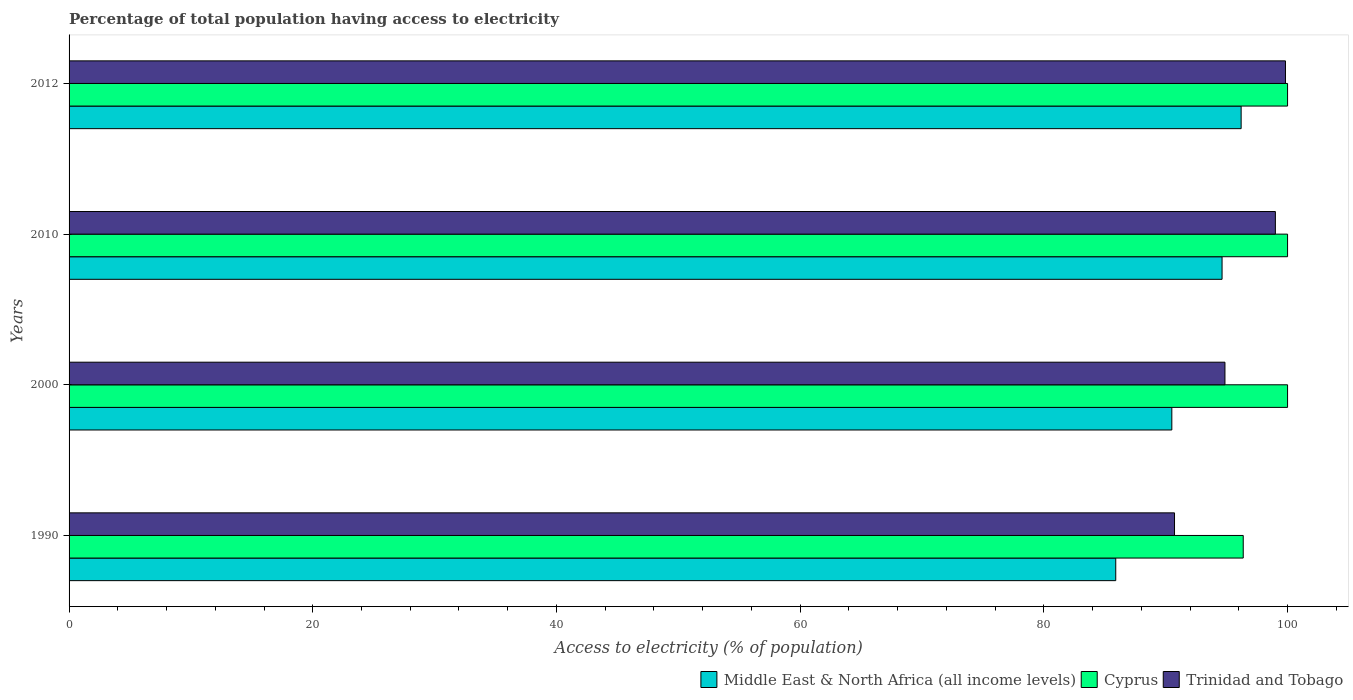How many different coloured bars are there?
Provide a short and direct response. 3. What is the label of the 2nd group of bars from the top?
Your answer should be compact. 2010. In how many cases, is the number of bars for a given year not equal to the number of legend labels?
Keep it short and to the point. 0. What is the percentage of population that have access to electricity in Middle East & North Africa (all income levels) in 2010?
Make the answer very short. 94.62. Across all years, what is the maximum percentage of population that have access to electricity in Cyprus?
Your answer should be compact. 100. Across all years, what is the minimum percentage of population that have access to electricity in Trinidad and Tobago?
Make the answer very short. 90.72. What is the total percentage of population that have access to electricity in Middle East & North Africa (all income levels) in the graph?
Your response must be concise. 367.21. What is the difference between the percentage of population that have access to electricity in Middle East & North Africa (all income levels) in 1990 and that in 2010?
Offer a very short reply. -8.73. What is the difference between the percentage of population that have access to electricity in Trinidad and Tobago in 1990 and the percentage of population that have access to electricity in Cyprus in 2010?
Keep it short and to the point. -9.28. What is the average percentage of population that have access to electricity in Middle East & North Africa (all income levels) per year?
Give a very brief answer. 91.8. In the year 1990, what is the difference between the percentage of population that have access to electricity in Trinidad and Tobago and percentage of population that have access to electricity in Middle East & North Africa (all income levels)?
Keep it short and to the point. 4.82. What is the ratio of the percentage of population that have access to electricity in Cyprus in 1990 to that in 2000?
Provide a succinct answer. 0.96. Is the difference between the percentage of population that have access to electricity in Trinidad and Tobago in 1990 and 2012 greater than the difference between the percentage of population that have access to electricity in Middle East & North Africa (all income levels) in 1990 and 2012?
Offer a very short reply. Yes. What is the difference between the highest and the lowest percentage of population that have access to electricity in Trinidad and Tobago?
Offer a very short reply. 9.11. Is the sum of the percentage of population that have access to electricity in Middle East & North Africa (all income levels) in 2000 and 2010 greater than the maximum percentage of population that have access to electricity in Trinidad and Tobago across all years?
Your answer should be very brief. Yes. What does the 2nd bar from the top in 1990 represents?
Your answer should be compact. Cyprus. What does the 3rd bar from the bottom in 2010 represents?
Your answer should be very brief. Trinidad and Tobago. Is it the case that in every year, the sum of the percentage of population that have access to electricity in Trinidad and Tobago and percentage of population that have access to electricity in Middle East & North Africa (all income levels) is greater than the percentage of population that have access to electricity in Cyprus?
Offer a terse response. Yes. How many bars are there?
Your response must be concise. 12. What is the difference between two consecutive major ticks on the X-axis?
Provide a succinct answer. 20. Are the values on the major ticks of X-axis written in scientific E-notation?
Your answer should be very brief. No. How many legend labels are there?
Offer a terse response. 3. How are the legend labels stacked?
Give a very brief answer. Horizontal. What is the title of the graph?
Make the answer very short. Percentage of total population having access to electricity. What is the label or title of the X-axis?
Make the answer very short. Access to electricity (% of population). What is the label or title of the Y-axis?
Provide a succinct answer. Years. What is the Access to electricity (% of population) in Middle East & North Africa (all income levels) in 1990?
Keep it short and to the point. 85.9. What is the Access to electricity (% of population) in Cyprus in 1990?
Provide a short and direct response. 96.36. What is the Access to electricity (% of population) of Trinidad and Tobago in 1990?
Offer a terse response. 90.72. What is the Access to electricity (% of population) in Middle East & North Africa (all income levels) in 2000?
Give a very brief answer. 90.5. What is the Access to electricity (% of population) of Cyprus in 2000?
Your response must be concise. 100. What is the Access to electricity (% of population) of Trinidad and Tobago in 2000?
Your answer should be compact. 94.86. What is the Access to electricity (% of population) of Middle East & North Africa (all income levels) in 2010?
Provide a short and direct response. 94.62. What is the Access to electricity (% of population) of Cyprus in 2010?
Ensure brevity in your answer.  100. What is the Access to electricity (% of population) in Middle East & North Africa (all income levels) in 2012?
Your answer should be very brief. 96.19. What is the Access to electricity (% of population) in Cyprus in 2012?
Your answer should be compact. 100. What is the Access to electricity (% of population) in Trinidad and Tobago in 2012?
Your answer should be compact. 99.83. Across all years, what is the maximum Access to electricity (% of population) of Middle East & North Africa (all income levels)?
Offer a terse response. 96.19. Across all years, what is the maximum Access to electricity (% of population) in Trinidad and Tobago?
Your answer should be compact. 99.83. Across all years, what is the minimum Access to electricity (% of population) of Middle East & North Africa (all income levels)?
Your answer should be very brief. 85.9. Across all years, what is the minimum Access to electricity (% of population) in Cyprus?
Give a very brief answer. 96.36. Across all years, what is the minimum Access to electricity (% of population) in Trinidad and Tobago?
Offer a very short reply. 90.72. What is the total Access to electricity (% of population) of Middle East & North Africa (all income levels) in the graph?
Your response must be concise. 367.21. What is the total Access to electricity (% of population) in Cyprus in the graph?
Ensure brevity in your answer.  396.36. What is the total Access to electricity (% of population) in Trinidad and Tobago in the graph?
Keep it short and to the point. 384.41. What is the difference between the Access to electricity (% of population) in Middle East & North Africa (all income levels) in 1990 and that in 2000?
Ensure brevity in your answer.  -4.6. What is the difference between the Access to electricity (% of population) of Cyprus in 1990 and that in 2000?
Offer a terse response. -3.64. What is the difference between the Access to electricity (% of population) in Trinidad and Tobago in 1990 and that in 2000?
Make the answer very short. -4.14. What is the difference between the Access to electricity (% of population) in Middle East & North Africa (all income levels) in 1990 and that in 2010?
Make the answer very short. -8.73. What is the difference between the Access to electricity (% of population) in Cyprus in 1990 and that in 2010?
Your response must be concise. -3.64. What is the difference between the Access to electricity (% of population) of Trinidad and Tobago in 1990 and that in 2010?
Your response must be concise. -8.28. What is the difference between the Access to electricity (% of population) in Middle East & North Africa (all income levels) in 1990 and that in 2012?
Offer a terse response. -10.29. What is the difference between the Access to electricity (% of population) in Cyprus in 1990 and that in 2012?
Keep it short and to the point. -3.64. What is the difference between the Access to electricity (% of population) of Trinidad and Tobago in 1990 and that in 2012?
Provide a succinct answer. -9.11. What is the difference between the Access to electricity (% of population) in Middle East & North Africa (all income levels) in 2000 and that in 2010?
Ensure brevity in your answer.  -4.12. What is the difference between the Access to electricity (% of population) in Cyprus in 2000 and that in 2010?
Your answer should be compact. 0. What is the difference between the Access to electricity (% of population) in Trinidad and Tobago in 2000 and that in 2010?
Your answer should be compact. -4.14. What is the difference between the Access to electricity (% of population) of Middle East & North Africa (all income levels) in 2000 and that in 2012?
Make the answer very short. -5.69. What is the difference between the Access to electricity (% of population) of Cyprus in 2000 and that in 2012?
Give a very brief answer. 0. What is the difference between the Access to electricity (% of population) in Trinidad and Tobago in 2000 and that in 2012?
Provide a short and direct response. -4.97. What is the difference between the Access to electricity (% of population) of Middle East & North Africa (all income levels) in 2010 and that in 2012?
Ensure brevity in your answer.  -1.56. What is the difference between the Access to electricity (% of population) in Cyprus in 2010 and that in 2012?
Keep it short and to the point. 0. What is the difference between the Access to electricity (% of population) of Trinidad and Tobago in 2010 and that in 2012?
Keep it short and to the point. -0.83. What is the difference between the Access to electricity (% of population) in Middle East & North Africa (all income levels) in 1990 and the Access to electricity (% of population) in Cyprus in 2000?
Ensure brevity in your answer.  -14.1. What is the difference between the Access to electricity (% of population) in Middle East & North Africa (all income levels) in 1990 and the Access to electricity (% of population) in Trinidad and Tobago in 2000?
Offer a very short reply. -8.96. What is the difference between the Access to electricity (% of population) of Cyprus in 1990 and the Access to electricity (% of population) of Trinidad and Tobago in 2000?
Offer a very short reply. 1.5. What is the difference between the Access to electricity (% of population) of Middle East & North Africa (all income levels) in 1990 and the Access to electricity (% of population) of Cyprus in 2010?
Keep it short and to the point. -14.1. What is the difference between the Access to electricity (% of population) of Middle East & North Africa (all income levels) in 1990 and the Access to electricity (% of population) of Trinidad and Tobago in 2010?
Your response must be concise. -13.1. What is the difference between the Access to electricity (% of population) of Cyprus in 1990 and the Access to electricity (% of population) of Trinidad and Tobago in 2010?
Keep it short and to the point. -2.64. What is the difference between the Access to electricity (% of population) of Middle East & North Africa (all income levels) in 1990 and the Access to electricity (% of population) of Cyprus in 2012?
Give a very brief answer. -14.1. What is the difference between the Access to electricity (% of population) in Middle East & North Africa (all income levels) in 1990 and the Access to electricity (% of population) in Trinidad and Tobago in 2012?
Keep it short and to the point. -13.93. What is the difference between the Access to electricity (% of population) in Cyprus in 1990 and the Access to electricity (% of population) in Trinidad and Tobago in 2012?
Your answer should be very brief. -3.47. What is the difference between the Access to electricity (% of population) in Middle East & North Africa (all income levels) in 2000 and the Access to electricity (% of population) in Cyprus in 2010?
Your answer should be compact. -9.5. What is the difference between the Access to electricity (% of population) of Middle East & North Africa (all income levels) in 2000 and the Access to electricity (% of population) of Trinidad and Tobago in 2010?
Ensure brevity in your answer.  -8.5. What is the difference between the Access to electricity (% of population) of Middle East & North Africa (all income levels) in 2000 and the Access to electricity (% of population) of Cyprus in 2012?
Keep it short and to the point. -9.5. What is the difference between the Access to electricity (% of population) in Middle East & North Africa (all income levels) in 2000 and the Access to electricity (% of population) in Trinidad and Tobago in 2012?
Keep it short and to the point. -9.33. What is the difference between the Access to electricity (% of population) of Cyprus in 2000 and the Access to electricity (% of population) of Trinidad and Tobago in 2012?
Your response must be concise. 0.17. What is the difference between the Access to electricity (% of population) in Middle East & North Africa (all income levels) in 2010 and the Access to electricity (% of population) in Cyprus in 2012?
Give a very brief answer. -5.38. What is the difference between the Access to electricity (% of population) of Middle East & North Africa (all income levels) in 2010 and the Access to electricity (% of population) of Trinidad and Tobago in 2012?
Offer a terse response. -5.2. What is the difference between the Access to electricity (% of population) in Cyprus in 2010 and the Access to electricity (% of population) in Trinidad and Tobago in 2012?
Your answer should be compact. 0.17. What is the average Access to electricity (% of population) in Middle East & North Africa (all income levels) per year?
Ensure brevity in your answer.  91.8. What is the average Access to electricity (% of population) of Cyprus per year?
Make the answer very short. 99.09. What is the average Access to electricity (% of population) in Trinidad and Tobago per year?
Your response must be concise. 96.1. In the year 1990, what is the difference between the Access to electricity (% of population) in Middle East & North Africa (all income levels) and Access to electricity (% of population) in Cyprus?
Offer a very short reply. -10.46. In the year 1990, what is the difference between the Access to electricity (% of population) in Middle East & North Africa (all income levels) and Access to electricity (% of population) in Trinidad and Tobago?
Make the answer very short. -4.82. In the year 1990, what is the difference between the Access to electricity (% of population) of Cyprus and Access to electricity (% of population) of Trinidad and Tobago?
Your answer should be very brief. 5.64. In the year 2000, what is the difference between the Access to electricity (% of population) of Middle East & North Africa (all income levels) and Access to electricity (% of population) of Cyprus?
Offer a terse response. -9.5. In the year 2000, what is the difference between the Access to electricity (% of population) of Middle East & North Africa (all income levels) and Access to electricity (% of population) of Trinidad and Tobago?
Offer a very short reply. -4.36. In the year 2000, what is the difference between the Access to electricity (% of population) in Cyprus and Access to electricity (% of population) in Trinidad and Tobago?
Your answer should be compact. 5.14. In the year 2010, what is the difference between the Access to electricity (% of population) of Middle East & North Africa (all income levels) and Access to electricity (% of population) of Cyprus?
Offer a terse response. -5.38. In the year 2010, what is the difference between the Access to electricity (% of population) of Middle East & North Africa (all income levels) and Access to electricity (% of population) of Trinidad and Tobago?
Keep it short and to the point. -4.38. In the year 2012, what is the difference between the Access to electricity (% of population) of Middle East & North Africa (all income levels) and Access to electricity (% of population) of Cyprus?
Provide a short and direct response. -3.81. In the year 2012, what is the difference between the Access to electricity (% of population) in Middle East & North Africa (all income levels) and Access to electricity (% of population) in Trinidad and Tobago?
Offer a very short reply. -3.64. In the year 2012, what is the difference between the Access to electricity (% of population) in Cyprus and Access to electricity (% of population) in Trinidad and Tobago?
Make the answer very short. 0.17. What is the ratio of the Access to electricity (% of population) in Middle East & North Africa (all income levels) in 1990 to that in 2000?
Provide a succinct answer. 0.95. What is the ratio of the Access to electricity (% of population) in Cyprus in 1990 to that in 2000?
Provide a succinct answer. 0.96. What is the ratio of the Access to electricity (% of population) in Trinidad and Tobago in 1990 to that in 2000?
Give a very brief answer. 0.96. What is the ratio of the Access to electricity (% of population) in Middle East & North Africa (all income levels) in 1990 to that in 2010?
Ensure brevity in your answer.  0.91. What is the ratio of the Access to electricity (% of population) in Cyprus in 1990 to that in 2010?
Give a very brief answer. 0.96. What is the ratio of the Access to electricity (% of population) in Trinidad and Tobago in 1990 to that in 2010?
Keep it short and to the point. 0.92. What is the ratio of the Access to electricity (% of population) in Middle East & North Africa (all income levels) in 1990 to that in 2012?
Keep it short and to the point. 0.89. What is the ratio of the Access to electricity (% of population) of Cyprus in 1990 to that in 2012?
Your response must be concise. 0.96. What is the ratio of the Access to electricity (% of population) in Trinidad and Tobago in 1990 to that in 2012?
Provide a succinct answer. 0.91. What is the ratio of the Access to electricity (% of population) of Middle East & North Africa (all income levels) in 2000 to that in 2010?
Your response must be concise. 0.96. What is the ratio of the Access to electricity (% of population) in Trinidad and Tobago in 2000 to that in 2010?
Ensure brevity in your answer.  0.96. What is the ratio of the Access to electricity (% of population) in Middle East & North Africa (all income levels) in 2000 to that in 2012?
Give a very brief answer. 0.94. What is the ratio of the Access to electricity (% of population) in Trinidad and Tobago in 2000 to that in 2012?
Offer a terse response. 0.95. What is the ratio of the Access to electricity (% of population) in Middle East & North Africa (all income levels) in 2010 to that in 2012?
Your answer should be compact. 0.98. What is the ratio of the Access to electricity (% of population) in Cyprus in 2010 to that in 2012?
Offer a terse response. 1. What is the ratio of the Access to electricity (% of population) of Trinidad and Tobago in 2010 to that in 2012?
Offer a terse response. 0.99. What is the difference between the highest and the second highest Access to electricity (% of population) in Middle East & North Africa (all income levels)?
Keep it short and to the point. 1.56. What is the difference between the highest and the second highest Access to electricity (% of population) in Trinidad and Tobago?
Ensure brevity in your answer.  0.83. What is the difference between the highest and the lowest Access to electricity (% of population) in Middle East & North Africa (all income levels)?
Provide a short and direct response. 10.29. What is the difference between the highest and the lowest Access to electricity (% of population) of Cyprus?
Provide a short and direct response. 3.64. What is the difference between the highest and the lowest Access to electricity (% of population) of Trinidad and Tobago?
Keep it short and to the point. 9.11. 